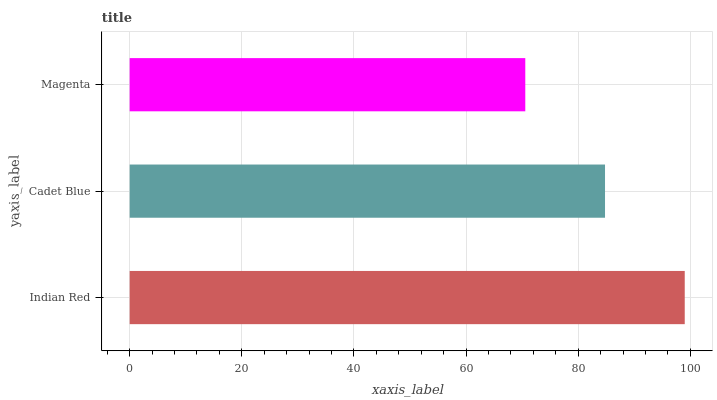Is Magenta the minimum?
Answer yes or no. Yes. Is Indian Red the maximum?
Answer yes or no. Yes. Is Cadet Blue the minimum?
Answer yes or no. No. Is Cadet Blue the maximum?
Answer yes or no. No. Is Indian Red greater than Cadet Blue?
Answer yes or no. Yes. Is Cadet Blue less than Indian Red?
Answer yes or no. Yes. Is Cadet Blue greater than Indian Red?
Answer yes or no. No. Is Indian Red less than Cadet Blue?
Answer yes or no. No. Is Cadet Blue the high median?
Answer yes or no. Yes. Is Cadet Blue the low median?
Answer yes or no. Yes. Is Magenta the high median?
Answer yes or no. No. Is Magenta the low median?
Answer yes or no. No. 